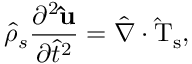Convert formula to latex. <formula><loc_0><loc_0><loc_500><loc_500>\hat { \rho } _ { s } \frac { \partial ^ { 2 } \hat { u } } { \partial \hat { t } ^ { 2 } } = \hat { \nabla } \cdot \hat { T } _ { s } ,</formula> 